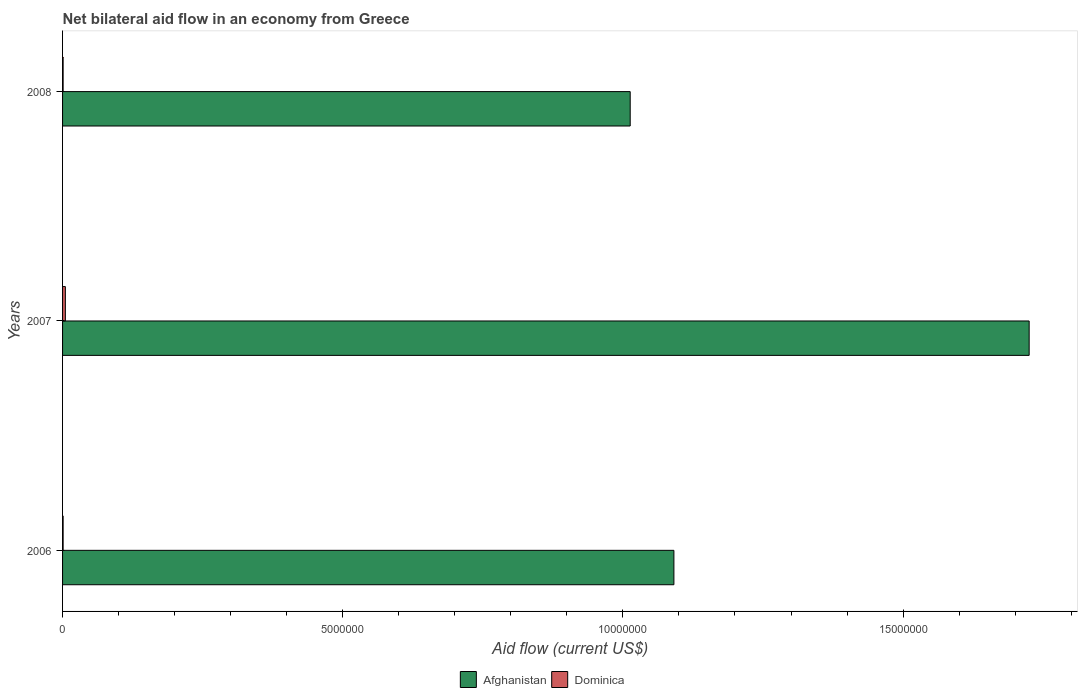How many different coloured bars are there?
Ensure brevity in your answer.  2. How many groups of bars are there?
Ensure brevity in your answer.  3. Are the number of bars on each tick of the Y-axis equal?
Provide a short and direct response. Yes. How many bars are there on the 3rd tick from the bottom?
Your answer should be compact. 2. What is the label of the 1st group of bars from the top?
Ensure brevity in your answer.  2008. In how many cases, is the number of bars for a given year not equal to the number of legend labels?
Offer a terse response. 0. What is the net bilateral aid flow in Afghanistan in 2008?
Offer a terse response. 1.01e+07. Across all years, what is the maximum net bilateral aid flow in Dominica?
Offer a terse response. 5.00e+04. Across all years, what is the minimum net bilateral aid flow in Afghanistan?
Offer a very short reply. 1.01e+07. In which year was the net bilateral aid flow in Dominica maximum?
Ensure brevity in your answer.  2007. In which year was the net bilateral aid flow in Dominica minimum?
Your response must be concise. 2006. What is the total net bilateral aid flow in Afghanistan in the graph?
Offer a very short reply. 3.83e+07. What is the difference between the net bilateral aid flow in Afghanistan in 2007 and that in 2008?
Make the answer very short. 7.12e+06. What is the difference between the net bilateral aid flow in Afghanistan in 2006 and the net bilateral aid flow in Dominica in 2008?
Offer a very short reply. 1.09e+07. What is the average net bilateral aid flow in Dominica per year?
Your answer should be compact. 2.33e+04. In the year 2007, what is the difference between the net bilateral aid flow in Dominica and net bilateral aid flow in Afghanistan?
Offer a terse response. -1.72e+07. In how many years, is the net bilateral aid flow in Dominica greater than 16000000 US$?
Offer a terse response. 0. What is the difference between the highest and the second highest net bilateral aid flow in Dominica?
Your answer should be compact. 4.00e+04. In how many years, is the net bilateral aid flow in Afghanistan greater than the average net bilateral aid flow in Afghanistan taken over all years?
Keep it short and to the point. 1. Is the sum of the net bilateral aid flow in Dominica in 2006 and 2007 greater than the maximum net bilateral aid flow in Afghanistan across all years?
Offer a very short reply. No. What does the 2nd bar from the top in 2006 represents?
Offer a very short reply. Afghanistan. What does the 1st bar from the bottom in 2008 represents?
Keep it short and to the point. Afghanistan. How many bars are there?
Your response must be concise. 6. How many years are there in the graph?
Offer a very short reply. 3. Are the values on the major ticks of X-axis written in scientific E-notation?
Make the answer very short. No. Does the graph contain any zero values?
Provide a short and direct response. No. How many legend labels are there?
Provide a succinct answer. 2. What is the title of the graph?
Offer a very short reply. Net bilateral aid flow in an economy from Greece. Does "India" appear as one of the legend labels in the graph?
Your response must be concise. No. What is the Aid flow (current US$) in Afghanistan in 2006?
Ensure brevity in your answer.  1.09e+07. What is the Aid flow (current US$) in Dominica in 2006?
Make the answer very short. 10000. What is the Aid flow (current US$) in Afghanistan in 2007?
Your answer should be very brief. 1.72e+07. What is the Aid flow (current US$) of Afghanistan in 2008?
Provide a succinct answer. 1.01e+07. What is the Aid flow (current US$) of Dominica in 2008?
Make the answer very short. 10000. Across all years, what is the maximum Aid flow (current US$) of Afghanistan?
Give a very brief answer. 1.72e+07. Across all years, what is the minimum Aid flow (current US$) in Afghanistan?
Your response must be concise. 1.01e+07. What is the total Aid flow (current US$) of Afghanistan in the graph?
Your response must be concise. 3.83e+07. What is the difference between the Aid flow (current US$) of Afghanistan in 2006 and that in 2007?
Your response must be concise. -6.34e+06. What is the difference between the Aid flow (current US$) in Dominica in 2006 and that in 2007?
Provide a succinct answer. -4.00e+04. What is the difference between the Aid flow (current US$) of Afghanistan in 2006 and that in 2008?
Your response must be concise. 7.80e+05. What is the difference between the Aid flow (current US$) of Afghanistan in 2007 and that in 2008?
Offer a terse response. 7.12e+06. What is the difference between the Aid flow (current US$) of Afghanistan in 2006 and the Aid flow (current US$) of Dominica in 2007?
Keep it short and to the point. 1.09e+07. What is the difference between the Aid flow (current US$) of Afghanistan in 2006 and the Aid flow (current US$) of Dominica in 2008?
Offer a terse response. 1.09e+07. What is the difference between the Aid flow (current US$) in Afghanistan in 2007 and the Aid flow (current US$) in Dominica in 2008?
Give a very brief answer. 1.72e+07. What is the average Aid flow (current US$) of Afghanistan per year?
Make the answer very short. 1.28e+07. What is the average Aid flow (current US$) of Dominica per year?
Offer a terse response. 2.33e+04. In the year 2006, what is the difference between the Aid flow (current US$) in Afghanistan and Aid flow (current US$) in Dominica?
Give a very brief answer. 1.09e+07. In the year 2007, what is the difference between the Aid flow (current US$) of Afghanistan and Aid flow (current US$) of Dominica?
Your response must be concise. 1.72e+07. In the year 2008, what is the difference between the Aid flow (current US$) of Afghanistan and Aid flow (current US$) of Dominica?
Offer a very short reply. 1.01e+07. What is the ratio of the Aid flow (current US$) in Afghanistan in 2006 to that in 2007?
Ensure brevity in your answer.  0.63. What is the ratio of the Aid flow (current US$) in Dominica in 2006 to that in 2007?
Offer a very short reply. 0.2. What is the ratio of the Aid flow (current US$) of Afghanistan in 2006 to that in 2008?
Provide a succinct answer. 1.08. What is the ratio of the Aid flow (current US$) of Afghanistan in 2007 to that in 2008?
Offer a terse response. 1.7. What is the ratio of the Aid flow (current US$) of Dominica in 2007 to that in 2008?
Provide a succinct answer. 5. What is the difference between the highest and the second highest Aid flow (current US$) of Afghanistan?
Offer a terse response. 6.34e+06. What is the difference between the highest and the lowest Aid flow (current US$) in Afghanistan?
Offer a terse response. 7.12e+06. 